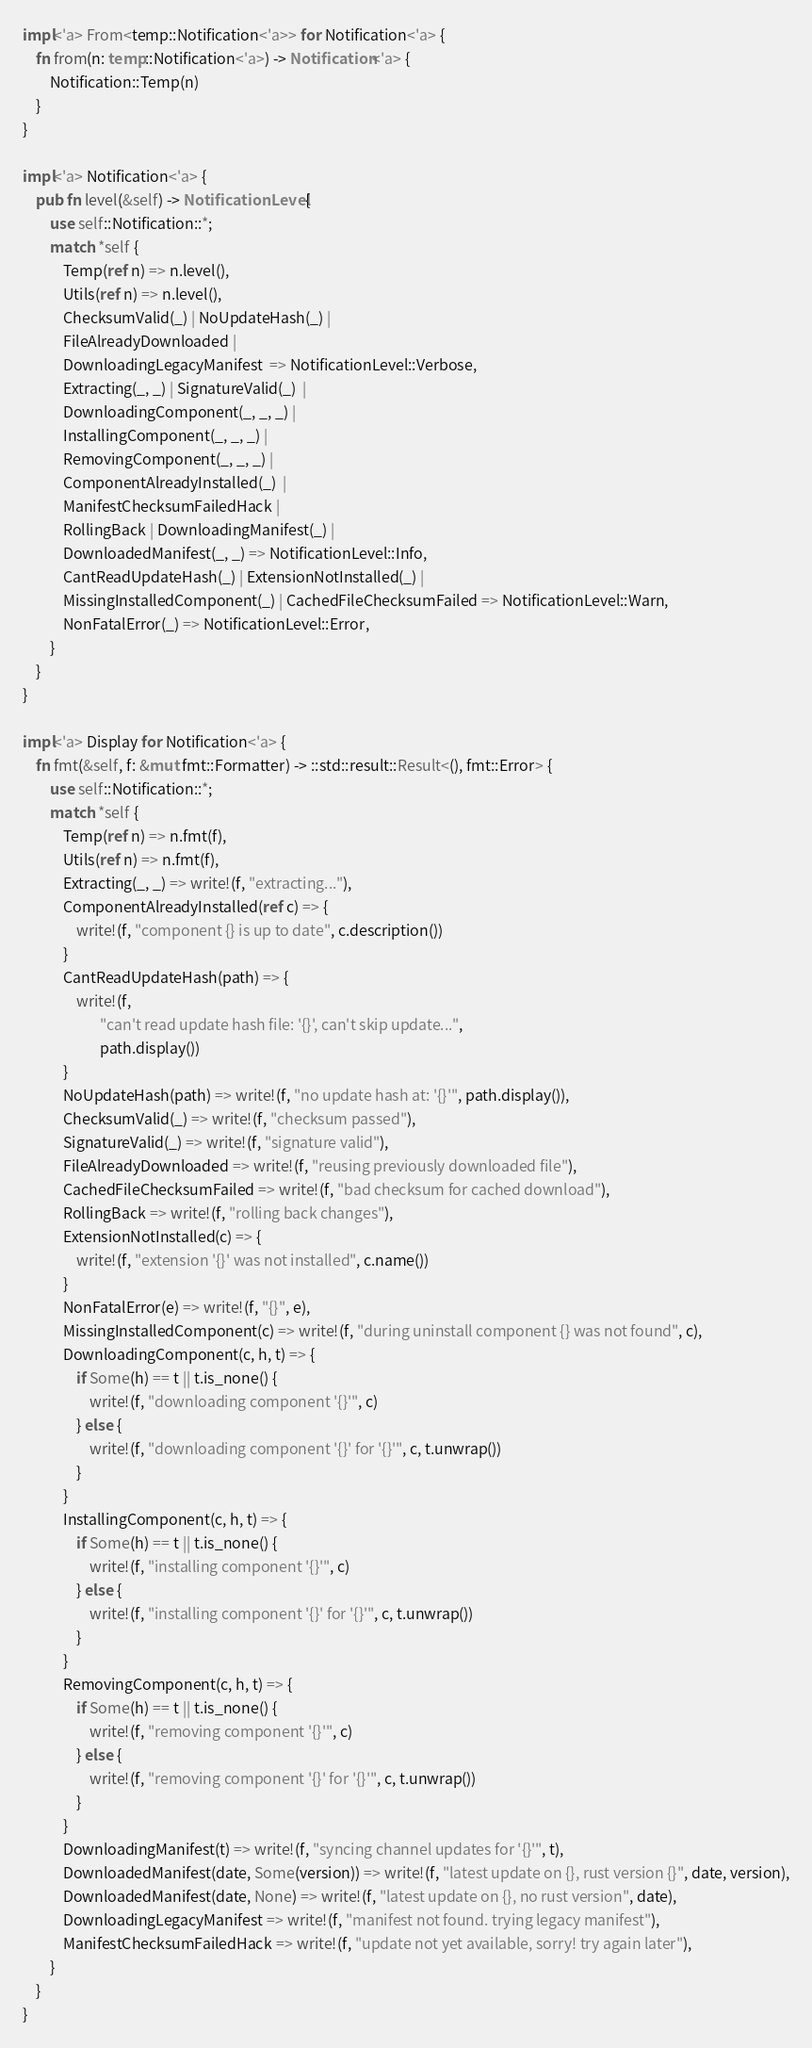<code> <loc_0><loc_0><loc_500><loc_500><_Rust_>
impl<'a> From<temp::Notification<'a>> for Notification<'a> {
    fn from(n: temp::Notification<'a>) -> Notification<'a> {
        Notification::Temp(n)
    }
}

impl<'a> Notification<'a> {
    pub fn level(&self) -> NotificationLevel {
        use self::Notification::*;
        match *self {
            Temp(ref n) => n.level(),
            Utils(ref n) => n.level(),
            ChecksumValid(_) | NoUpdateHash(_) |
            FileAlreadyDownloaded |
            DownloadingLegacyManifest  => NotificationLevel::Verbose,
            Extracting(_, _) | SignatureValid(_)  |
            DownloadingComponent(_, _, _) |
            InstallingComponent(_, _, _) |
            RemovingComponent(_, _, _) |
            ComponentAlreadyInstalled(_)  |
            ManifestChecksumFailedHack |
            RollingBack | DownloadingManifest(_) |
            DownloadedManifest(_, _) => NotificationLevel::Info,
            CantReadUpdateHash(_) | ExtensionNotInstalled(_) |
            MissingInstalledComponent(_) | CachedFileChecksumFailed => NotificationLevel::Warn,
            NonFatalError(_) => NotificationLevel::Error,
        }
    }
}

impl<'a> Display for Notification<'a> {
    fn fmt(&self, f: &mut fmt::Formatter) -> ::std::result::Result<(), fmt::Error> {
        use self::Notification::*;
        match *self {
            Temp(ref n) => n.fmt(f),
            Utils(ref n) => n.fmt(f),
            Extracting(_, _) => write!(f, "extracting..."),
            ComponentAlreadyInstalled(ref c) => {
                write!(f, "component {} is up to date", c.description())
            }
            CantReadUpdateHash(path) => {
                write!(f,
                       "can't read update hash file: '{}', can't skip update...",
                       path.display())
            }
            NoUpdateHash(path) => write!(f, "no update hash at: '{}'", path.display()),
            ChecksumValid(_) => write!(f, "checksum passed"),
            SignatureValid(_) => write!(f, "signature valid"),
            FileAlreadyDownloaded => write!(f, "reusing previously downloaded file"),
            CachedFileChecksumFailed => write!(f, "bad checksum for cached download"),
            RollingBack => write!(f, "rolling back changes"),
            ExtensionNotInstalled(c) => {
                write!(f, "extension '{}' was not installed", c.name())
            }
            NonFatalError(e) => write!(f, "{}", e),
            MissingInstalledComponent(c) => write!(f, "during uninstall component {} was not found", c),
            DownloadingComponent(c, h, t) => {
                if Some(h) == t || t.is_none() {
                    write!(f, "downloading component '{}'", c)
                } else {
                    write!(f, "downloading component '{}' for '{}'", c, t.unwrap())
                }
            }
            InstallingComponent(c, h, t) => {
                if Some(h) == t || t.is_none() {
                    write!(f, "installing component '{}'", c)
                } else {
                    write!(f, "installing component '{}' for '{}'", c, t.unwrap())
                }
            }
            RemovingComponent(c, h, t) => {
                if Some(h) == t || t.is_none() {
                    write!(f, "removing component '{}'", c)
                } else {
                    write!(f, "removing component '{}' for '{}'", c, t.unwrap())
                }
            }
            DownloadingManifest(t) => write!(f, "syncing channel updates for '{}'", t),
            DownloadedManifest(date, Some(version)) => write!(f, "latest update on {}, rust version {}", date, version),
            DownloadedManifest(date, None) => write!(f, "latest update on {}, no rust version", date),
            DownloadingLegacyManifest => write!(f, "manifest not found. trying legacy manifest"),
            ManifestChecksumFailedHack => write!(f, "update not yet available, sorry! try again later"),
        }
    }
}
</code> 